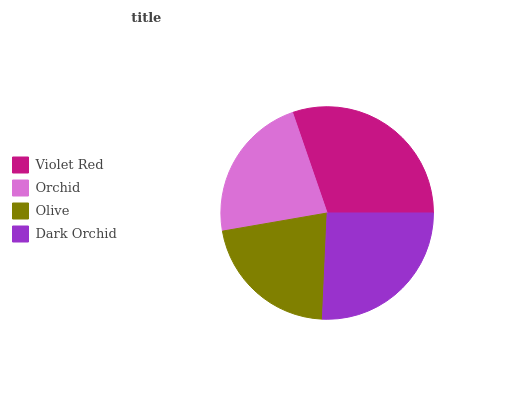Is Olive the minimum?
Answer yes or no. Yes. Is Violet Red the maximum?
Answer yes or no. Yes. Is Orchid the minimum?
Answer yes or no. No. Is Orchid the maximum?
Answer yes or no. No. Is Violet Red greater than Orchid?
Answer yes or no. Yes. Is Orchid less than Violet Red?
Answer yes or no. Yes. Is Orchid greater than Violet Red?
Answer yes or no. No. Is Violet Red less than Orchid?
Answer yes or no. No. Is Dark Orchid the high median?
Answer yes or no. Yes. Is Orchid the low median?
Answer yes or no. Yes. Is Olive the high median?
Answer yes or no. No. Is Dark Orchid the low median?
Answer yes or no. No. 